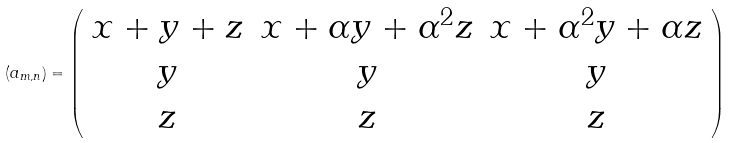Convert formula to latex. <formula><loc_0><loc_0><loc_500><loc_500>( a _ { m , n } ) = \left ( \begin{array} { c c c } x + y + z & x + \alpha y + \alpha ^ { 2 } z & x + \alpha ^ { 2 } y + \alpha z \\ y & y & y \\ z & z & z \\ \end{array} \right )</formula> 